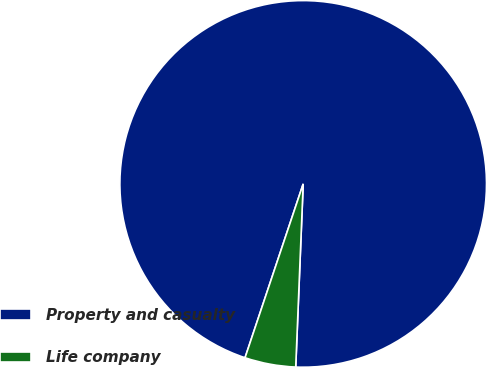Convert chart. <chart><loc_0><loc_0><loc_500><loc_500><pie_chart><fcel>Property and casualty<fcel>Life company<nl><fcel>95.51%<fcel>4.49%<nl></chart> 